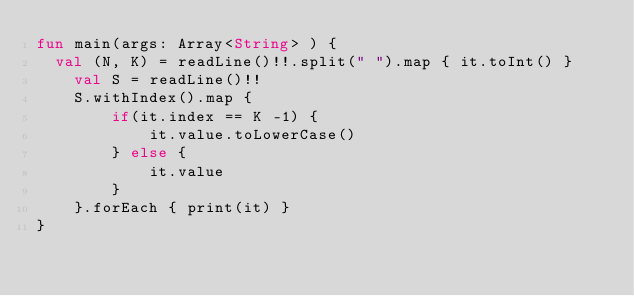Convert code to text. <code><loc_0><loc_0><loc_500><loc_500><_Kotlin_>fun main(args: Array<String> ) {
  val (N, K) = readLine()!!.split(" ").map { it.toInt() }
    val S = readLine()!!
    S.withIndex().map {
        if(it.index == K -1) {
            it.value.toLowerCase()
        } else {
            it.value
        }
    }.forEach { print(it) }
}</code> 